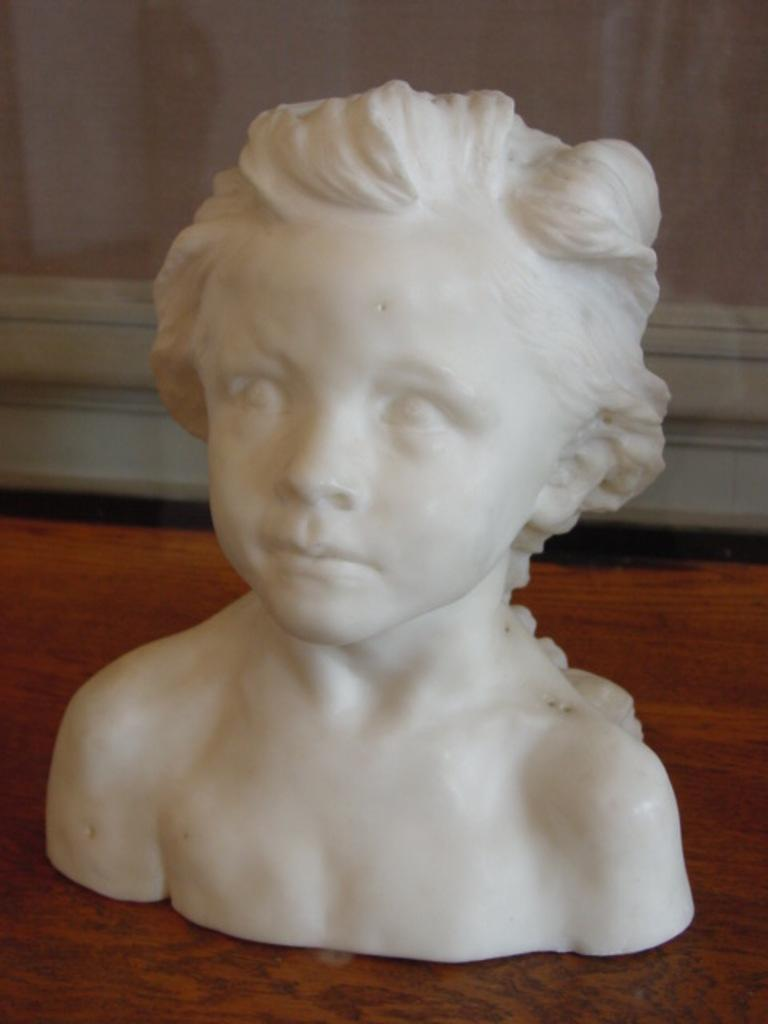Where was the image taken? The image is taken indoors. What is located at the bottom of the image? There is a table at the bottom of the image. What can be seen in the background of the image? There is a window in the background of the image. What is the main subject in the middle of the image? There is a sculpture in the middle of the image. Where is the sculpture placed? The sculpture is on the table. What type of comfort can be seen in the image? There is no specific comfort item present in the image. How does the sponge contribute to the image? There is no sponge present in the image. 